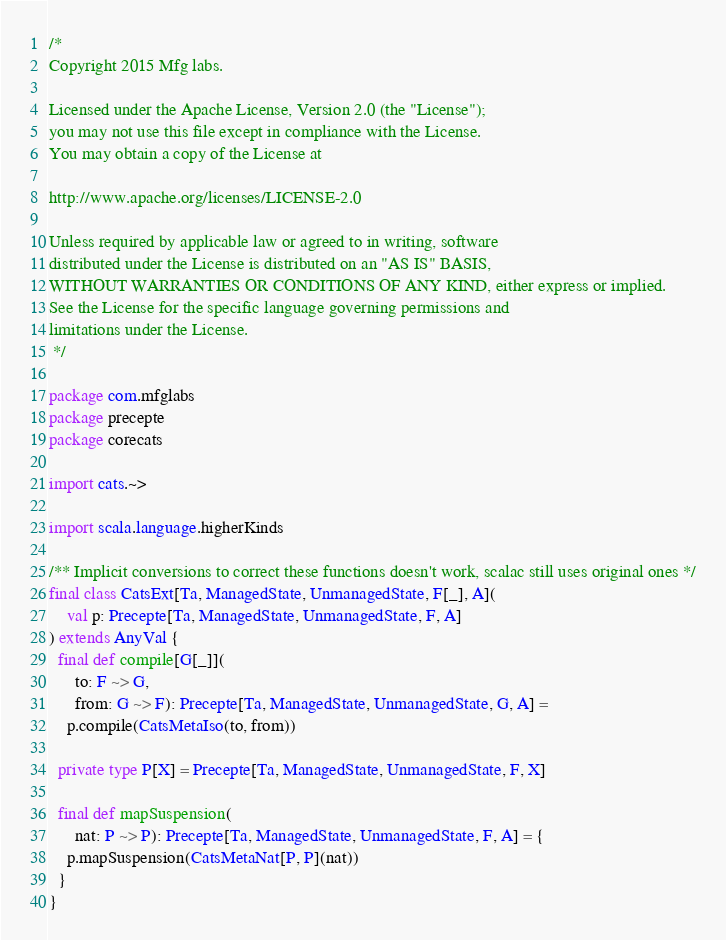Convert code to text. <code><loc_0><loc_0><loc_500><loc_500><_Scala_>/*
Copyright 2015 Mfg labs.

Licensed under the Apache License, Version 2.0 (the "License");
you may not use this file except in compliance with the License.
You may obtain a copy of the License at

http://www.apache.org/licenses/LICENSE-2.0

Unless required by applicable law or agreed to in writing, software
distributed under the License is distributed on an "AS IS" BASIS,
WITHOUT WARRANTIES OR CONDITIONS OF ANY KIND, either express or implied.
See the License for the specific language governing permissions and
limitations under the License.
 */

package com.mfglabs
package precepte
package corecats

import cats.~>

import scala.language.higherKinds

/** Implicit conversions to correct these functions doesn't work, scalac still uses original ones */
final class CatsExt[Ta, ManagedState, UnmanagedState, F[_], A](
    val p: Precepte[Ta, ManagedState, UnmanagedState, F, A]
) extends AnyVal {
  final def compile[G[_]](
      to: F ~> G,
      from: G ~> F): Precepte[Ta, ManagedState, UnmanagedState, G, A] =
    p.compile(CatsMetaIso(to, from))

  private type P[X] = Precepte[Ta, ManagedState, UnmanagedState, F, X]

  final def mapSuspension(
      nat: P ~> P): Precepte[Ta, ManagedState, UnmanagedState, F, A] = {
    p.mapSuspension(CatsMetaNat[P, P](nat))
  }
}
</code> 